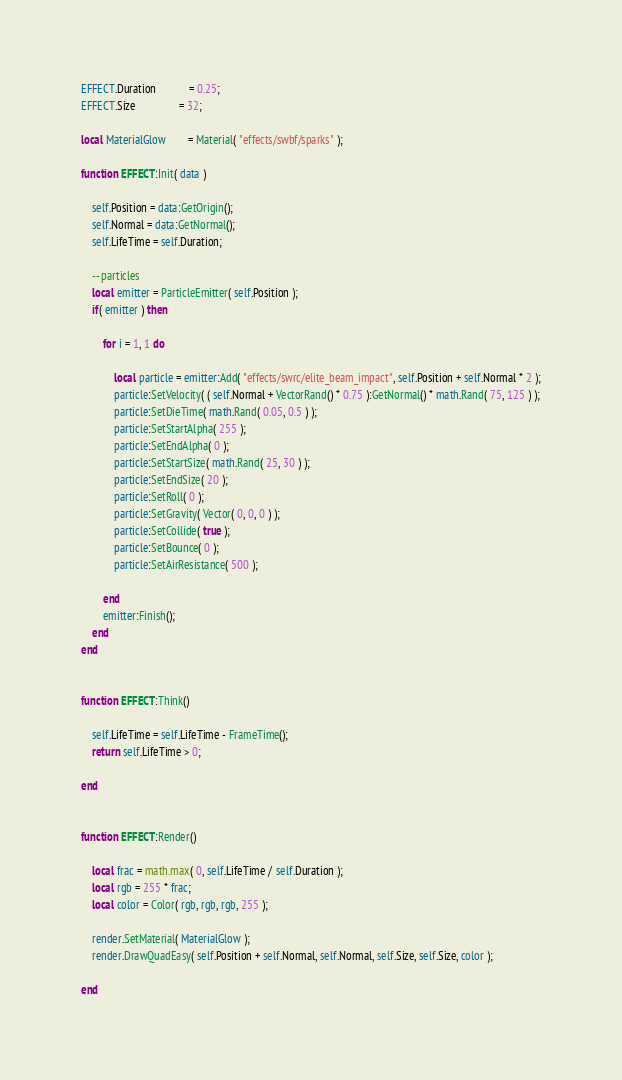Convert code to text. <code><loc_0><loc_0><loc_500><loc_500><_Lua_>EFFECT.Duration			= 0.25;
EFFECT.Size				= 32;

local MaterialGlow		= Material( "effects/swbf/sparks" );

function EFFECT:Init( data )

	self.Position = data:GetOrigin();
	self.Normal = data:GetNormal();
	self.LifeTime = self.Duration;

	-- particles
	local emitter = ParticleEmitter( self.Position );
	if( emitter ) then
		
		for i = 1, 1 do

			local particle = emitter:Add( "effects/swrc/elite_beam_impact", self.Position + self.Normal * 2 );
			particle:SetVelocity( ( self.Normal + VectorRand() * 0.75 ):GetNormal() * math.Rand( 75, 125 ) );
			particle:SetDieTime( math.Rand( 0.05, 0.5 ) );
			particle:SetStartAlpha( 255 );
			particle:SetEndAlpha( 0 );
			particle:SetStartSize( math.Rand( 25, 30 ) );
			particle:SetEndSize( 20 );
			particle:SetRoll( 0 );
			particle:SetGravity( Vector( 0, 0, 0 ) );
			particle:SetCollide( true );
			particle:SetBounce( 0 );
			particle:SetAirResistance( 500 );

		end
		emitter:Finish();
	end
end


function EFFECT:Think()

	self.LifeTime = self.LifeTime - FrameTime();
	return self.LifeTime > 0;

end


function EFFECT:Render()

	local frac = math.max( 0, self.LifeTime / self.Duration );
	local rgb = 255 * frac;
	local color = Color( rgb, rgb, rgb, 255 );

	render.SetMaterial( MaterialGlow );
	render.DrawQuadEasy( self.Position + self.Normal, self.Normal, self.Size, self.Size, color );

end
</code> 